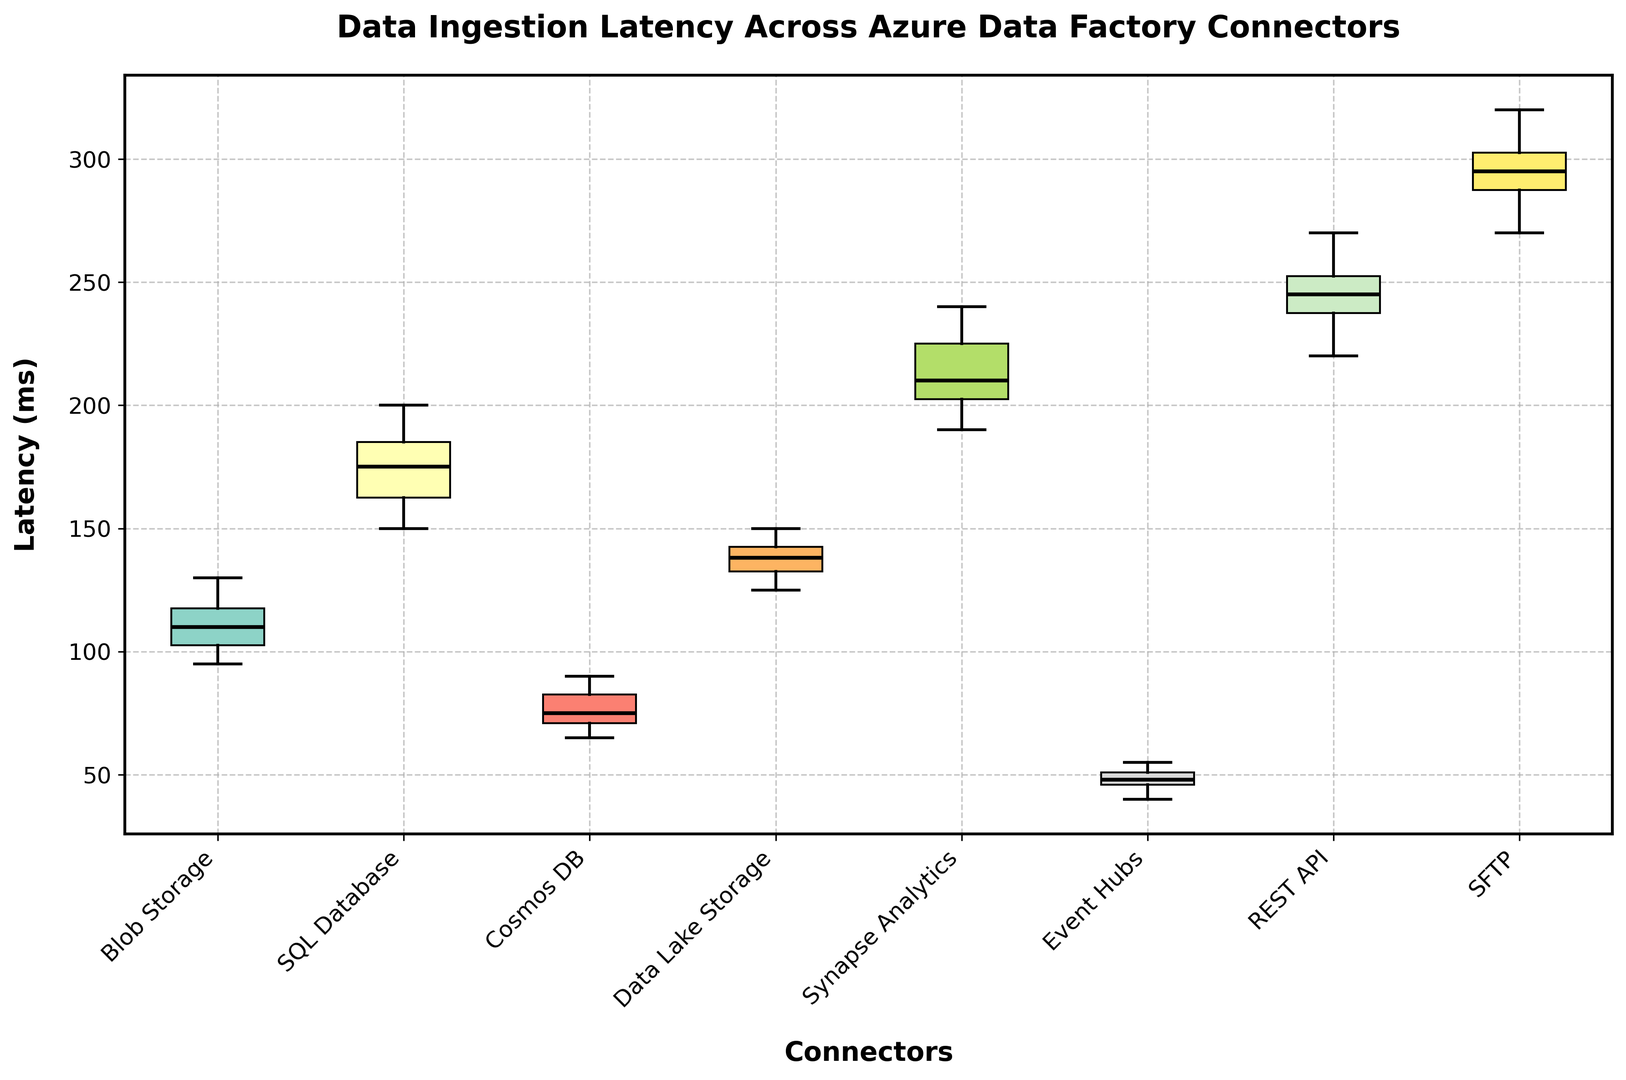Which connector has the highest median latency? The median latency can be identified by looking at the line inside each box plot. The box plot with the highest median line will correspond to the connector with the highest median latency.
Answer: SFTP Which connector has the widest range of latencies? The range of latencies can be identified by the distance between the top and bottom whiskers of each box plot. The connector with the widest spread will have the longest distance between its whiskers.
Answer: SFTP What is the approximate interquartile range (IQR) for the `REST API` connector? The interquartile range (IQR) can be determined by the length of the box itself, which represents the distance between the first quartile (Q1) and the third quartile (Q3). Measure the length of the box for the `REST API` connector.
Answer: 245 - 220 ≈ 25 ms How does the latency of `Event Hubs` compare to `Cosmos DB`? To compare latencies, look at both the median lines and the spread (whiskers) of the `Event Hubs` and `Cosmos DB` box plots. Compare both central tendency and variability.
Answer: Event Hubs has lower median latency and a similar spread compared to Cosmos DB What is the difference in median latencies between `Blob Storage` and `SQL Database`? Identify the median values (the line inside each box plot) for both `Blob Storage` and `SQL Database` and calculate the difference between these two median values.
Answer: 180 - 110 = 70 ms Which connectors have outliers, if any? Outliers are represented by points outside the whiskers of the box plots. Look for any points that lie beyond the range of whiskers for each connector to determine if there are outliers.
Answer: None Which connector shows the smallest variability in latencies? Variability can be assessed by the length between the upper and lower whiskers. The connector with the shortest distance between its whiskers has the smallest variability.
Answer: Event Hubs Is the median latency of `Synapse Analytics` closer to the maximum or minimum latency of `Data Lake Storage`? Determine the median latency of `Synapse Analytics` and compare it with the maximum and minimum values of `Data Lake Storage` (top and bottom whiskers) to see which one is closer.
Answer: Closer to the maximum Which connector has the lowest upper quartile (Q3) latency? The upper quartile (Q3) latency is found at the top edge of the box. Identify which connector has the lowest top edge of the box.
Answer: Event Hubs 